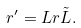<formula> <loc_0><loc_0><loc_500><loc_500>r ^ { \prime } = L r \tilde { L } .</formula> 